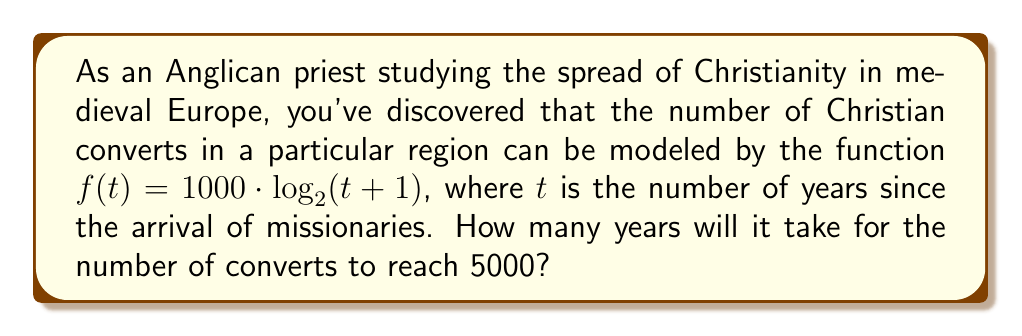What is the answer to this math problem? Let's approach this step-by-step:

1) We need to solve the equation:
   $5000 = 1000 \cdot \log_2(t + 1)$

2) Divide both sides by 1000:
   $5 = \log_2(t + 1)$

3) To solve for $t$, we need to apply the inverse function of $\log_2$, which is $2^x$:
   $2^5 = t + 1$

4) Simplify the left side:
   $32 = t + 1$

5) Subtract 1 from both sides:
   $31 = t$

Therefore, it will take 31 years for the number of converts to reach 5000.

This logarithmic model reflects the historical pattern of religious spread, where growth is rapid at first but slows down as the population of potential converts decreases.
Answer: 31 years 